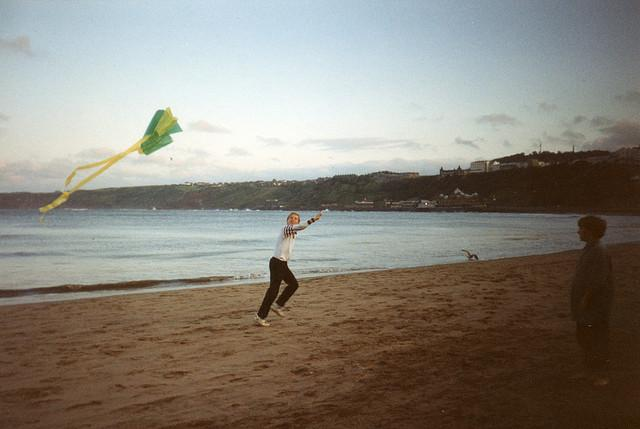Where is the kite in relation to the boy? behind 